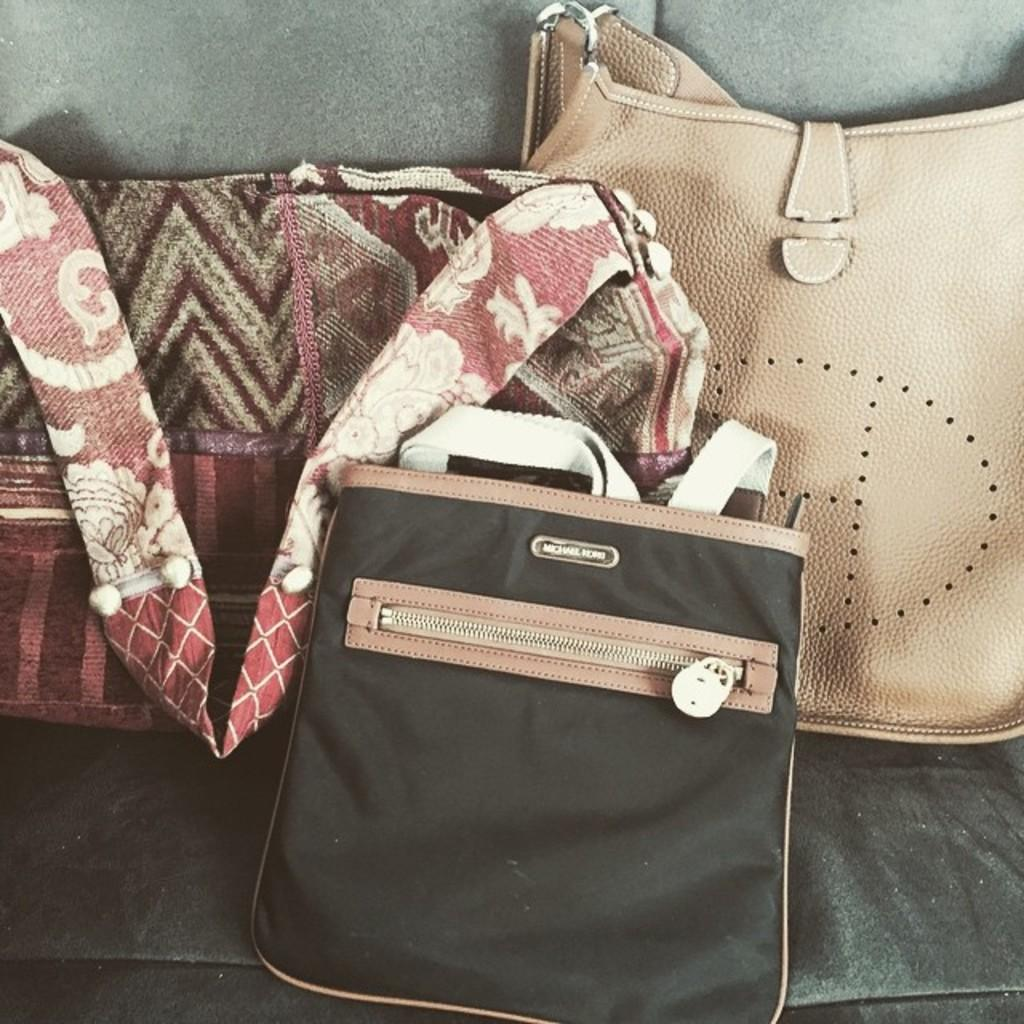How many handbags are visible in the image? There are three handbags in the image. What can be said about the variety of handbags in the handbags in the image? The handbags are of different types. Where are the handbags placed in the image? The handbags are placed on a sofa. What type of vase is placed on the jail in the image? There is no vase or jail present in the image. How can someone join the handbags in the image? There is no need to join the handbags in the image, as they are already together on the sofa. 